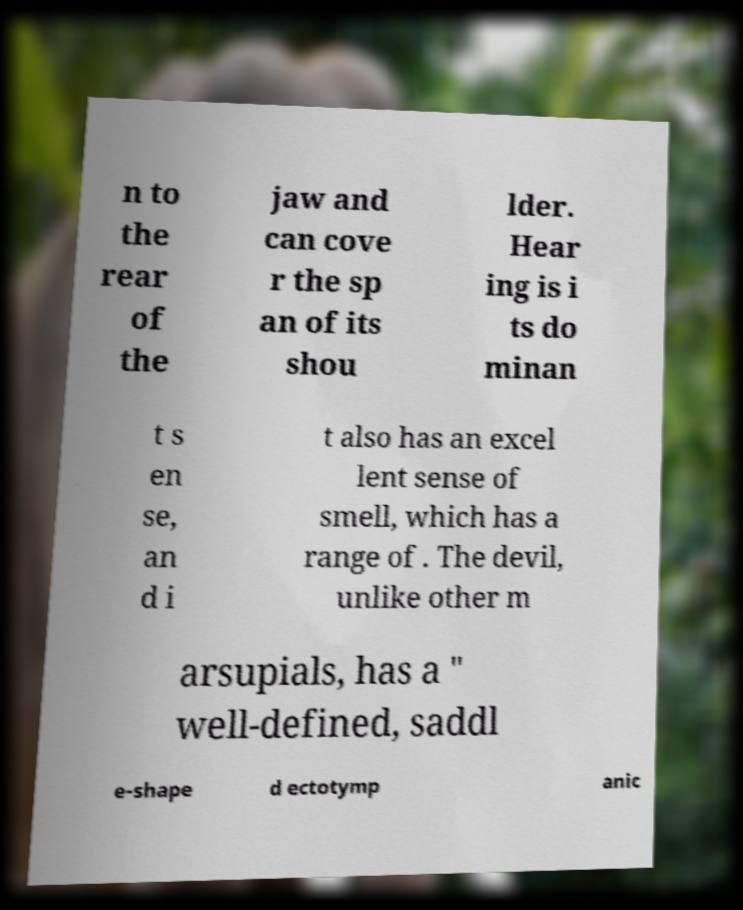Could you assist in decoding the text presented in this image and type it out clearly? n to the rear of the jaw and can cove r the sp an of its shou lder. Hear ing is i ts do minan t s en se, an d i t also has an excel lent sense of smell, which has a range of . The devil, unlike other m arsupials, has a " well-defined, saddl e-shape d ectotymp anic 